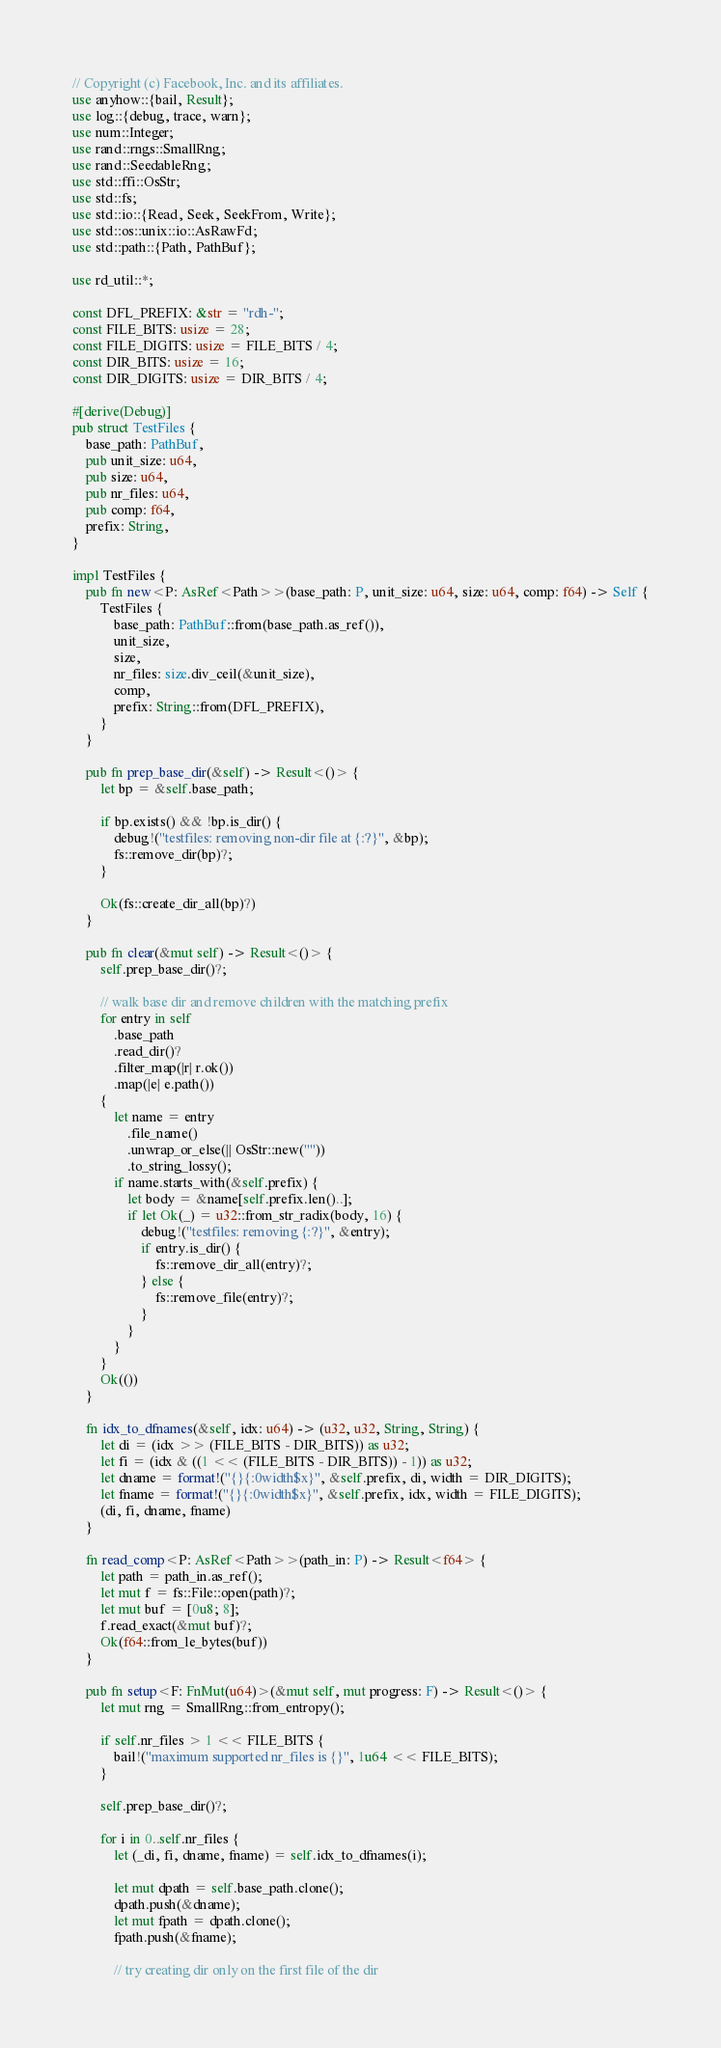Convert code to text. <code><loc_0><loc_0><loc_500><loc_500><_Rust_>// Copyright (c) Facebook, Inc. and its affiliates.
use anyhow::{bail, Result};
use log::{debug, trace, warn};
use num::Integer;
use rand::rngs::SmallRng;
use rand::SeedableRng;
use std::ffi::OsStr;
use std::fs;
use std::io::{Read, Seek, SeekFrom, Write};
use std::os::unix::io::AsRawFd;
use std::path::{Path, PathBuf};

use rd_util::*;

const DFL_PREFIX: &str = "rdh-";
const FILE_BITS: usize = 28;
const FILE_DIGITS: usize = FILE_BITS / 4;
const DIR_BITS: usize = 16;
const DIR_DIGITS: usize = DIR_BITS / 4;

#[derive(Debug)]
pub struct TestFiles {
    base_path: PathBuf,
    pub unit_size: u64,
    pub size: u64,
    pub nr_files: u64,
    pub comp: f64,
    prefix: String,
}

impl TestFiles {
    pub fn new<P: AsRef<Path>>(base_path: P, unit_size: u64, size: u64, comp: f64) -> Self {
        TestFiles {
            base_path: PathBuf::from(base_path.as_ref()),
            unit_size,
            size,
            nr_files: size.div_ceil(&unit_size),
            comp,
            prefix: String::from(DFL_PREFIX),
        }
    }

    pub fn prep_base_dir(&self) -> Result<()> {
        let bp = &self.base_path;

        if bp.exists() && !bp.is_dir() {
            debug!("testfiles: removing non-dir file at {:?}", &bp);
            fs::remove_dir(bp)?;
        }

        Ok(fs::create_dir_all(bp)?)
    }

    pub fn clear(&mut self) -> Result<()> {
        self.prep_base_dir()?;

        // walk base dir and remove children with the matching prefix
        for entry in self
            .base_path
            .read_dir()?
            .filter_map(|r| r.ok())
            .map(|e| e.path())
        {
            let name = entry
                .file_name()
                .unwrap_or_else(|| OsStr::new(""))
                .to_string_lossy();
            if name.starts_with(&self.prefix) {
                let body = &name[self.prefix.len()..];
                if let Ok(_) = u32::from_str_radix(body, 16) {
                    debug!("testfiles: removing {:?}", &entry);
                    if entry.is_dir() {
                        fs::remove_dir_all(entry)?;
                    } else {
                        fs::remove_file(entry)?;
                    }
                }
            }
        }
        Ok(())
    }

    fn idx_to_dfnames(&self, idx: u64) -> (u32, u32, String, String) {
        let di = (idx >> (FILE_BITS - DIR_BITS)) as u32;
        let fi = (idx & ((1 << (FILE_BITS - DIR_BITS)) - 1)) as u32;
        let dname = format!("{}{:0width$x}", &self.prefix, di, width = DIR_DIGITS);
        let fname = format!("{}{:0width$x}", &self.prefix, idx, width = FILE_DIGITS);
        (di, fi, dname, fname)
    }

    fn read_comp<P: AsRef<Path>>(path_in: P) -> Result<f64> {
        let path = path_in.as_ref();
        let mut f = fs::File::open(path)?;
        let mut buf = [0u8; 8];
        f.read_exact(&mut buf)?;
        Ok(f64::from_le_bytes(buf))
    }

    pub fn setup<F: FnMut(u64)>(&mut self, mut progress: F) -> Result<()> {
        let mut rng = SmallRng::from_entropy();

        if self.nr_files > 1 << FILE_BITS {
            bail!("maximum supported nr_files is {}", 1u64 << FILE_BITS);
        }

        self.prep_base_dir()?;

        for i in 0..self.nr_files {
            let (_di, fi, dname, fname) = self.idx_to_dfnames(i);

            let mut dpath = self.base_path.clone();
            dpath.push(&dname);
            let mut fpath = dpath.clone();
            fpath.push(&fname);

            // try creating dir only on the first file of the dir</code> 